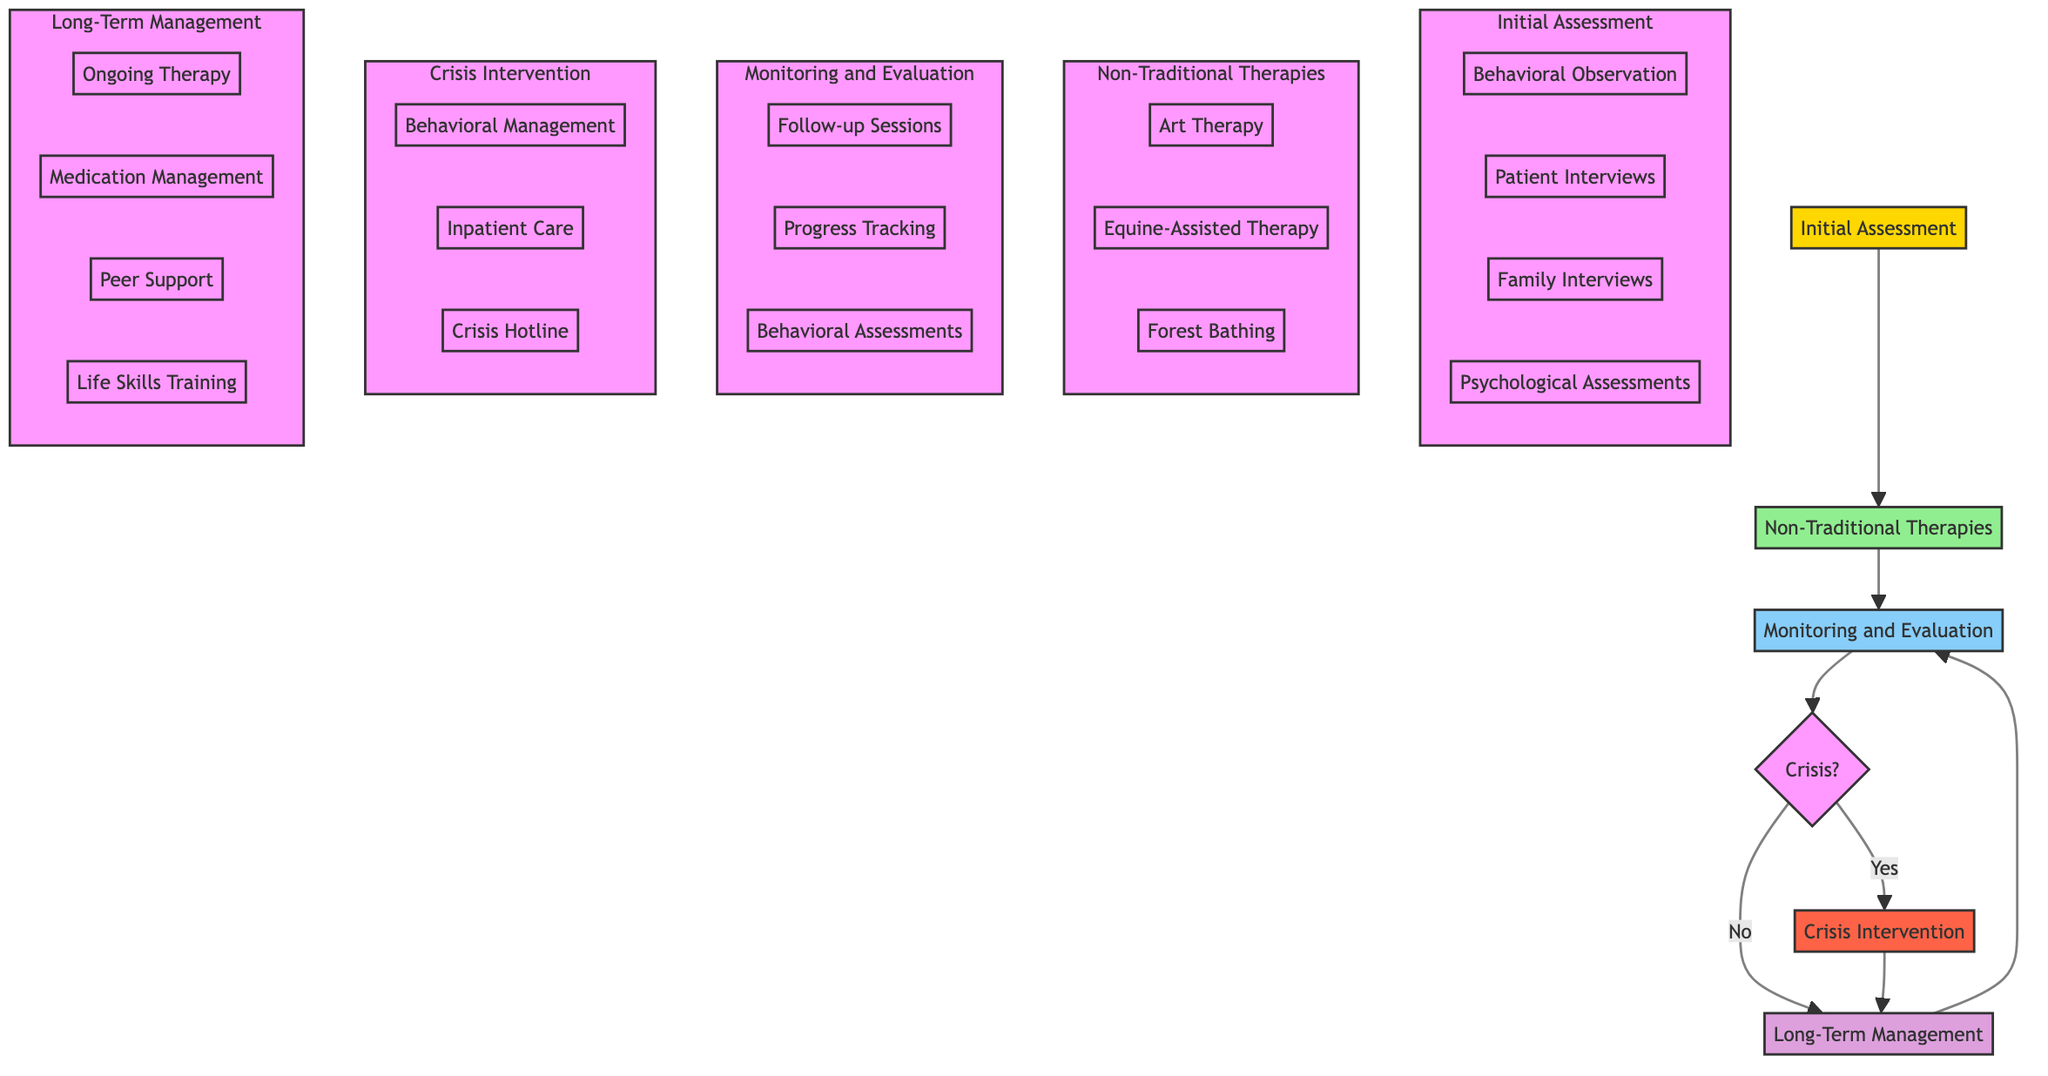What are the entities involved in the Initial Assessment? The Initial Assessment node lists three entities: Psychiatrist, Behavioral Specialist, and Social Worker.
Answer: Psychiatrist, Behavioral Specialist, Social Worker How many non-traditional therapies are included? The Non-Traditional Therapies section includes three therapies: Art Therapy, Equine-Assisted Therapy, and Forest Bathing.
Answer: 3 What follows after Monitoring and Evaluation if there is a crisis? If a crisis is identified (indicated by a "Yes" branch), the next step is Crisis Intervention.
Answer: Crisis Intervention How is progress evaluated in the Monitoring and Evaluation phase? Progress is tracked through Follow-up Sessions, Progress Tracking, and Behavioral Assessments. This is detailed in the Monitoring and Evaluation node.
Answer: Follow-up Sessions, Progress Tracking, Behavioral Assessments What type of care is provided during Crisis Intervention? The Crisis Intervention section mentions Immediate Behavioral Management, Temporary Inpatient Care, and 24/7 Crisis Hotline Support as the types of care provided.
Answer: Immediate Behavioral Management, Temporary Inpatient Care, 24/7 Crisis Hotline Support Which long-term management components are included? The Long-Term Management node lists four components: Ongoing Therapy Sessions, Medication Management, Peer Support Programs, and Life Skills Training.
Answer: Ongoing Therapy Sessions, Medication Management, Peer Support Programs, Life Skills Training Which therapeutic approach involves nature? Forest Bathing is the therapeutic approach that specifically involves interactions with nature to improve mental well-being.
Answer: Forest Bathing What is the first step in the pathway according to the diagram? The first step in the Clinical Pathway diagram is the Initial Assessment. This is the starting node that leads to Non-Traditional Therapies.
Answer: Initial Assessment 